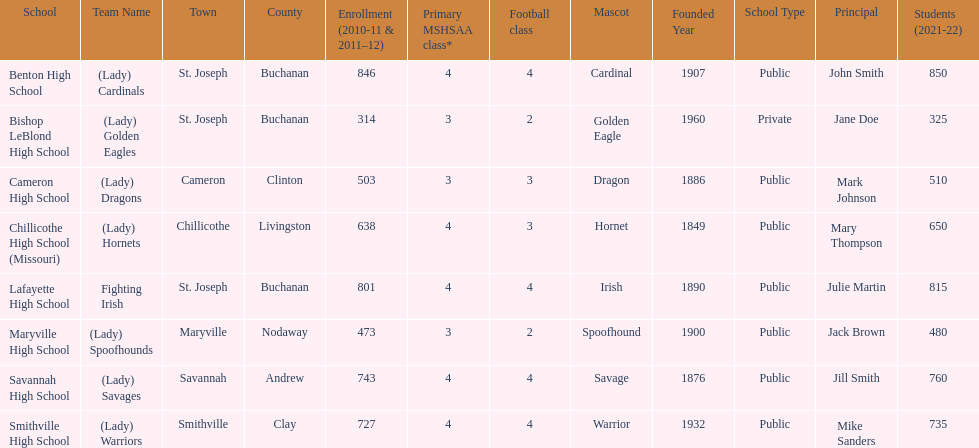How many of the schools had at least 500 students enrolled in the 2010-2011 and 2011-2012 season? 6. 